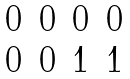<formula> <loc_0><loc_0><loc_500><loc_500>\begin{matrix} 0 & 0 & 0 & 0 \\ 0 & 0 & 1 & 1 \end{matrix}</formula> 